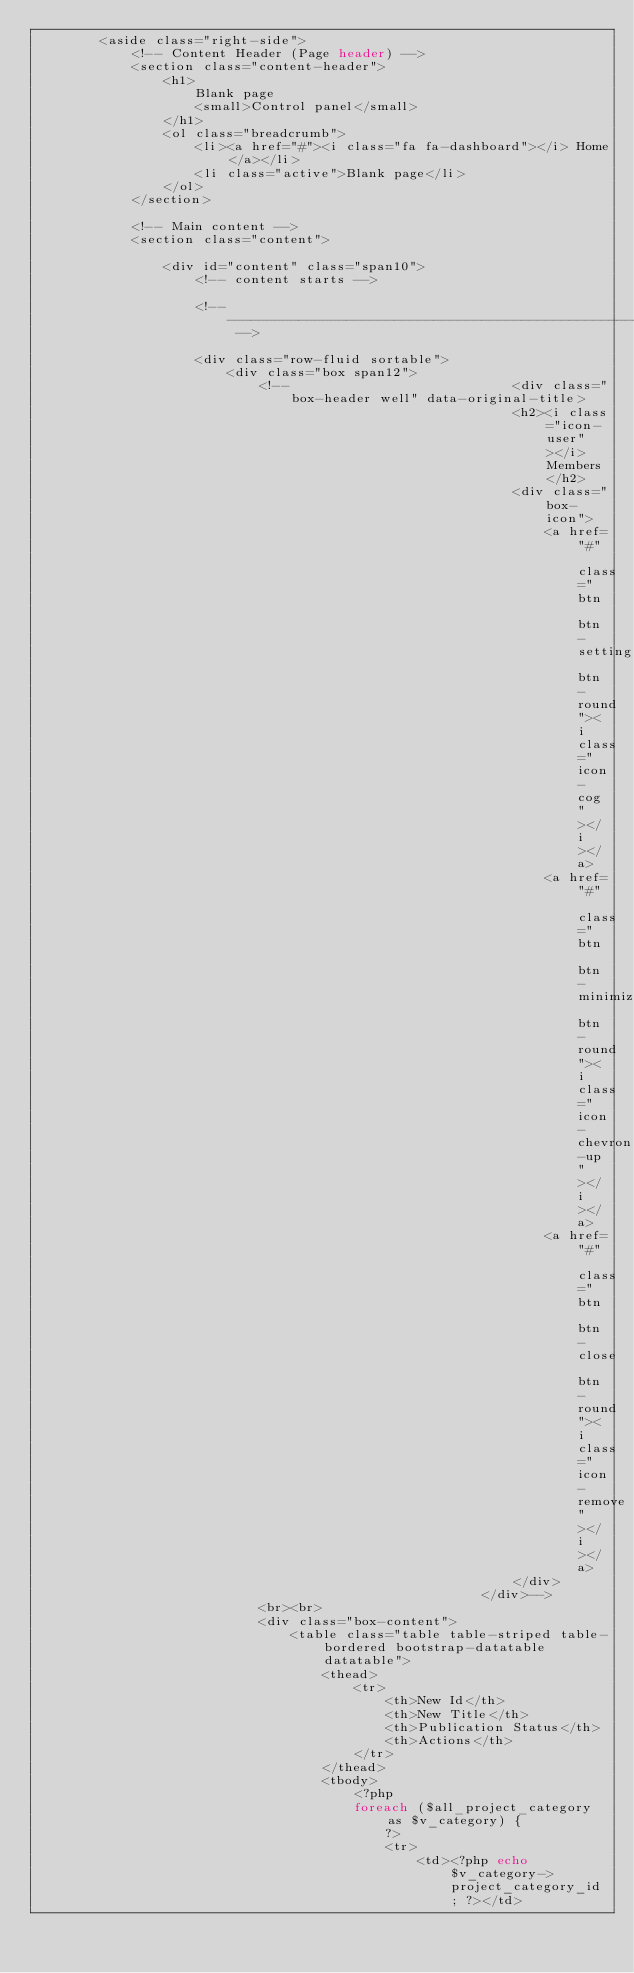<code> <loc_0><loc_0><loc_500><loc_500><_PHP_>        <aside class="right-side">                
            <!-- Content Header (Page header) -->
            <section class="content-header">
                <h1>
                    Blank page
                    <small>Control panel</small>
                </h1>
                <ol class="breadcrumb">
                    <li><a href="#"><i class="fa fa-dashboard"></i> Home</a></li>
                    <li class="active">Blank page</li>
                </ol>
            </section>

            <!-- Main content -->
            <section class="content">

                <div id="content" class="span10">
                    <!-- content starts -->

                    <!-- --------------------------------------------------------------------------------------- -->

                    <div class="row-fluid sortable">		
                        <div class="box span12">
                            <!--                            <div class="box-header well" data-original-title>
                                                            <h2><i class="icon-user"></i> Members</h2>
                                                            <div class="box-icon">
                                                                <a href="#" class="btn btn-setting btn-round"><i class="icon-cog"></i></a>
                                                                <a href="#" class="btn btn-minimize btn-round"><i class="icon-chevron-up"></i></a>
                                                                <a href="#" class="btn btn-close btn-round"><i class="icon-remove"></i></a>
                                                            </div>
                                                        </div>-->
                            <br><br>
                            <div class="box-content">
                                <table class="table table-striped table-bordered bootstrap-datatable datatable">
                                    <thead>
                                        <tr>
                                            <th>New Id</th>
                                            <th>New Title</th>
                                            <th>Publication Status</th>
                                            <th>Actions</th>
                                        </tr>
                                    </thead>   
                                    <tbody>
                                        <?php
                                        foreach ($all_project_category as $v_category) {
                                            ?>
                                            <tr>
                                                <td><?php echo $v_category->project_category_id; ?></td></code> 